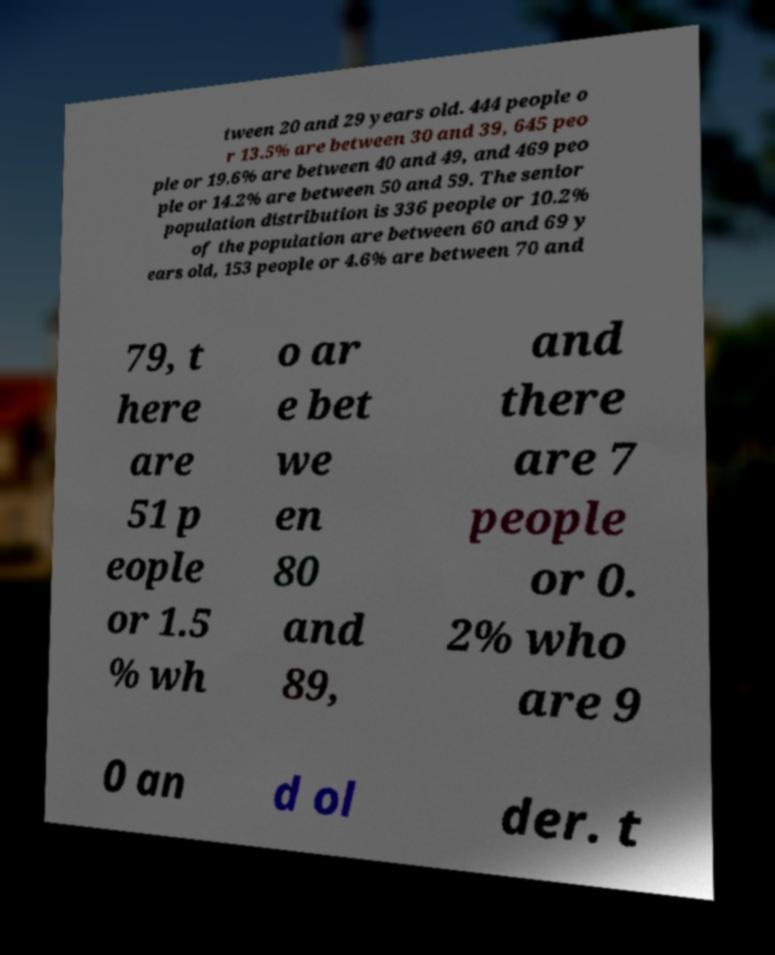Can you accurately transcribe the text from the provided image for me? tween 20 and 29 years old. 444 people o r 13.5% are between 30 and 39, 645 peo ple or 19.6% are between 40 and 49, and 469 peo ple or 14.2% are between 50 and 59. The senior population distribution is 336 people or 10.2% of the population are between 60 and 69 y ears old, 153 people or 4.6% are between 70 and 79, t here are 51 p eople or 1.5 % wh o ar e bet we en 80 and 89, and there are 7 people or 0. 2% who are 9 0 an d ol der. t 